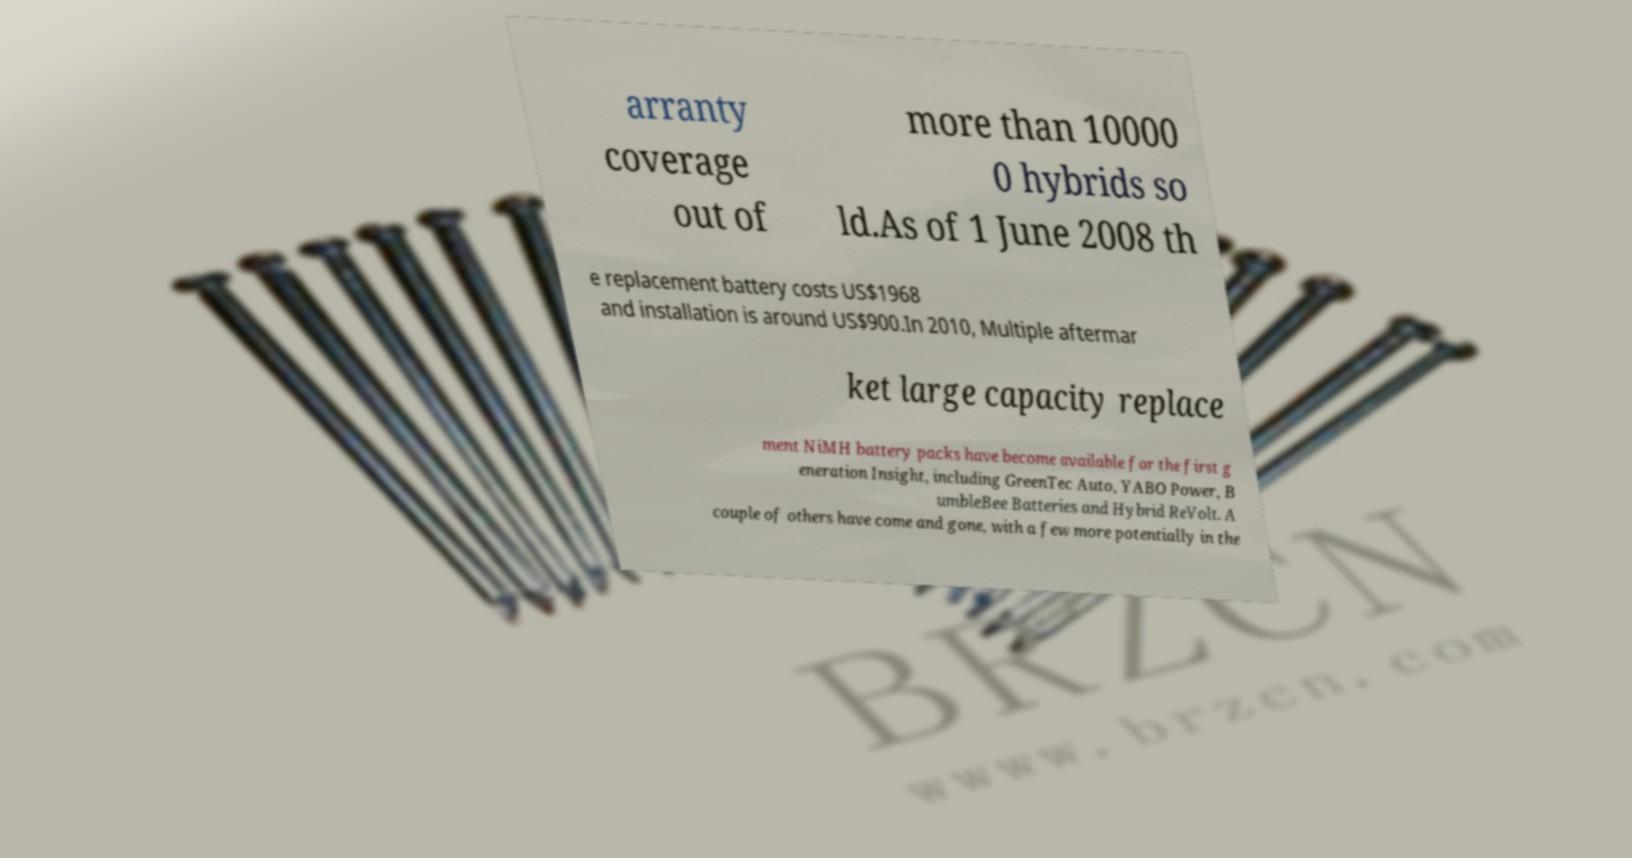Can you accurately transcribe the text from the provided image for me? arranty coverage out of more than 10000 0 hybrids so ld.As of 1 June 2008 th e replacement battery costs US$1968 and installation is around US$900.In 2010, Multiple aftermar ket large capacity replace ment NiMH battery packs have become available for the first g eneration Insight, including GreenTec Auto, YABO Power, B umbleBee Batteries and Hybrid ReVolt. A couple of others have come and gone, with a few more potentially in the 